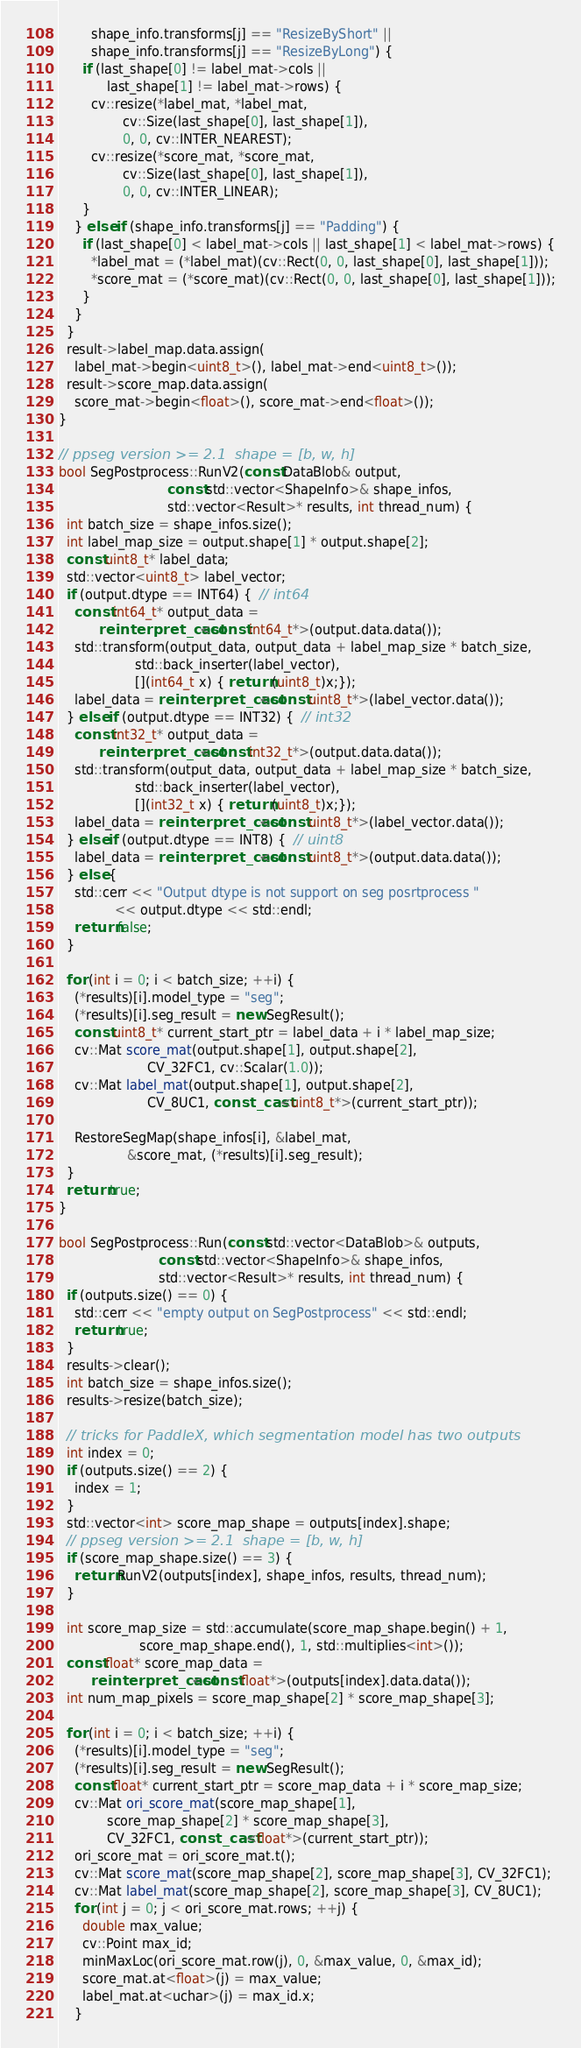Convert code to text. <code><loc_0><loc_0><loc_500><loc_500><_C++_>        shape_info.transforms[j] == "ResizeByShort" ||
        shape_info.transforms[j] == "ResizeByLong") {
      if (last_shape[0] != label_mat->cols ||
            last_shape[1] != label_mat->rows) {
        cv::resize(*label_mat, *label_mat,
                cv::Size(last_shape[0], last_shape[1]),
                0, 0, cv::INTER_NEAREST);
        cv::resize(*score_mat, *score_mat,
                cv::Size(last_shape[0], last_shape[1]),
                0, 0, cv::INTER_LINEAR);
      }
    } else if (shape_info.transforms[j] == "Padding") {
      if (last_shape[0] < label_mat->cols || last_shape[1] < label_mat->rows) {
        *label_mat = (*label_mat)(cv::Rect(0, 0, last_shape[0], last_shape[1]));
        *score_mat = (*score_mat)(cv::Rect(0, 0, last_shape[0], last_shape[1]));
      }
    }
  }
  result->label_map.data.assign(
    label_mat->begin<uint8_t>(), label_mat->end<uint8_t>());
  result->score_map.data.assign(
    score_mat->begin<float>(), score_mat->end<float>());
}

// ppseg version >= 2.1  shape = [b, w, h]
bool SegPostprocess::RunV2(const DataBlob& output,
                           const std::vector<ShapeInfo>& shape_infos,
                           std::vector<Result>* results, int thread_num) {
  int batch_size = shape_infos.size();
  int label_map_size = output.shape[1] * output.shape[2];
  const uint8_t* label_data;
  std::vector<uint8_t> label_vector;
  if (output.dtype == INT64) {  // int64
    const int64_t* output_data =
          reinterpret_cast<const int64_t*>(output.data.data());
    std::transform(output_data, output_data + label_map_size * batch_size,
                   std::back_inserter(label_vector),
                   [](int64_t x) { return (uint8_t)x;});
    label_data = reinterpret_cast<const uint8_t*>(label_vector.data());
  } else if (output.dtype == INT32) {  // int32
    const int32_t* output_data =
          reinterpret_cast<const int32_t*>(output.data.data());
    std::transform(output_data, output_data + label_map_size * batch_size,
                   std::back_inserter(label_vector),
                   [](int32_t x) { return (uint8_t)x;});
    label_data = reinterpret_cast<const uint8_t*>(label_vector.data());
  } else if (output.dtype == INT8) {  // uint8
    label_data = reinterpret_cast<const uint8_t*>(output.data.data());
  } else {
    std::cerr << "Output dtype is not support on seg posrtprocess "
              << output.dtype << std::endl;
    return false;
  }

  for (int i = 0; i < batch_size; ++i) {
    (*results)[i].model_type = "seg";
    (*results)[i].seg_result = new SegResult();
    const uint8_t* current_start_ptr = label_data + i * label_map_size;
    cv::Mat score_mat(output.shape[1], output.shape[2],
                      CV_32FC1, cv::Scalar(1.0));
    cv::Mat label_mat(output.shape[1], output.shape[2],
                      CV_8UC1, const_cast<uint8_t*>(current_start_ptr));

    RestoreSegMap(shape_infos[i], &label_mat,
                 &score_mat, (*results)[i].seg_result);
  }
  return true;
}

bool SegPostprocess::Run(const std::vector<DataBlob>& outputs,
                         const std::vector<ShapeInfo>& shape_infos,
                         std::vector<Result>* results, int thread_num) {
  if (outputs.size() == 0) {
    std::cerr << "empty output on SegPostprocess" << std::endl;
    return true;
  }
  results->clear();
  int batch_size = shape_infos.size();
  results->resize(batch_size);

  // tricks for PaddleX, which segmentation model has two outputs
  int index = 0;
  if (outputs.size() == 2) {
    index = 1;
  }
  std::vector<int> score_map_shape = outputs[index].shape;
  // ppseg version >= 2.1  shape = [b, w, h]
  if (score_map_shape.size() == 3) {
    return RunV2(outputs[index], shape_infos, results, thread_num);
  }

  int score_map_size = std::accumulate(score_map_shape.begin() + 1,
                    score_map_shape.end(), 1, std::multiplies<int>());
  const float* score_map_data =
        reinterpret_cast<const float*>(outputs[index].data.data());
  int num_map_pixels = score_map_shape[2] * score_map_shape[3];

  for (int i = 0; i < batch_size; ++i) {
    (*results)[i].model_type = "seg";
    (*results)[i].seg_result = new SegResult();
    const float* current_start_ptr = score_map_data + i * score_map_size;
    cv::Mat ori_score_mat(score_map_shape[1],
            score_map_shape[2] * score_map_shape[3],
            CV_32FC1, const_cast<float*>(current_start_ptr));
    ori_score_mat = ori_score_mat.t();
    cv::Mat score_mat(score_map_shape[2], score_map_shape[3], CV_32FC1);
    cv::Mat label_mat(score_map_shape[2], score_map_shape[3], CV_8UC1);
    for (int j = 0; j < ori_score_mat.rows; ++j) {
      double max_value;
      cv::Point max_id;
      minMaxLoc(ori_score_mat.row(j), 0, &max_value, 0, &max_id);
      score_mat.at<float>(j) = max_value;
      label_mat.at<uchar>(j) = max_id.x;
    }</code> 